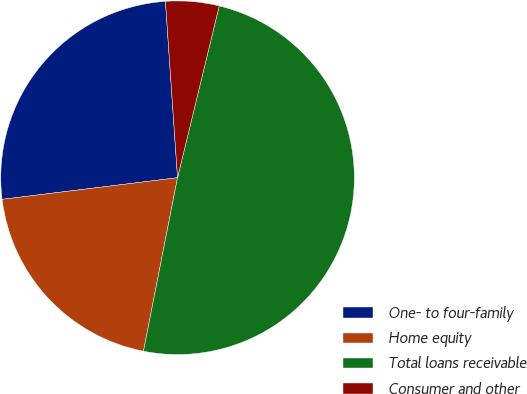Convert chart to OTSL. <chart><loc_0><loc_0><loc_500><loc_500><pie_chart><fcel>One- to four-family<fcel>Home equity<fcel>Total loans receivable<fcel>Consumer and other<nl><fcel>25.86%<fcel>19.96%<fcel>49.3%<fcel>4.88%<nl></chart> 